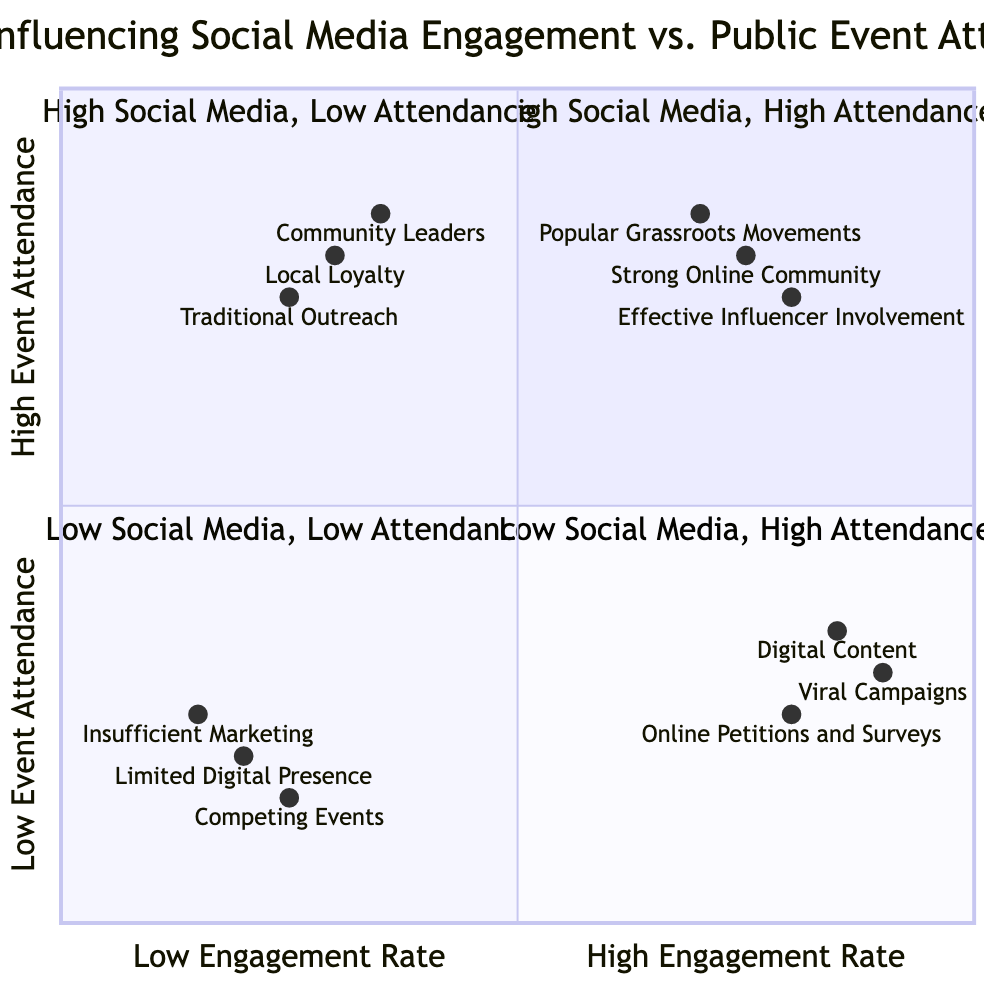What are the factors in the High Social Media Engagement, High Public Event Attendance quadrant? The diagram lists three factors in this quadrant: Strong Online Community, Popular Grassroots Movements, and Effective Influencer Involvement.
Answer: Strong Online Community, Popular Grassroots Movements, Effective Influencer Involvement Which factor shows the highest engagement rate in the High Social Media Engagement, Low Public Event Attendance quadrant? The factors in this quadrant include Viral Campaigns, Digital Content, and Online Petitions and Surveys. Comparing engagement rates, Viral Campaigns has the highest rate at 0.9.
Answer: Viral Campaigns How many factors are in the Low Social Media Engagement, High Event Attendance quadrant? Reviewing the diagram, this quadrant contains three factors: Local Loyalty, Traditional Outreach, and Community Leaders. Counting them gives a total of three.
Answer: 3 What is the relationship between limited digital presence and public event attendance? The Limited Digital Presence factor is located in the Low Social Media Engagement, Low Public Event Attendance quadrant, indicating a lower engagement rate and corresponding low attendance at public events.
Answer: Negative Which quadrant has the factors related to competing events and insufficient marketing? These factors are located in the Low Social Media Engagement, Low Public Event Attendance quadrant, indicating that both competing events and insufficient marketing affect both social media engagement and public attendance negatively.
Answer: Low Social Media Engagement, Low Public Event Attendance What is the engagement rate for the factor “Community Leaders”? The engagement rate for Community Leaders, located in the Low Social Media Engagement, High Public Event Attendance quadrant, is 0.35.
Answer: 0.35 Which quadrant features factors that indicate strong community support? The Low Social Media Engagement, High Public Event Attendance quadrant features factors that indicate strong community support, including Local Loyalty and Community Leaders.
Answer: Low Social Media Engagement, High Public Event Attendance What is the attendance metric level for Digital Content? The attendance metric level for Digital Content, which is in the High Social Media Engagement, Low Public Event Attendance quadrant, is described as a value of 0.35.
Answer: 0.35 